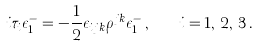Convert formula to latex. <formula><loc_0><loc_0><loc_500><loc_500>i \tau _ { i } \epsilon _ { 1 } ^ { - } = - \frac { 1 } { 2 } \epsilon _ { i j k } \rho ^ { j k } \epsilon _ { 1 } ^ { - } \, , \quad i = 1 , \, 2 , \, 3 \, .</formula> 